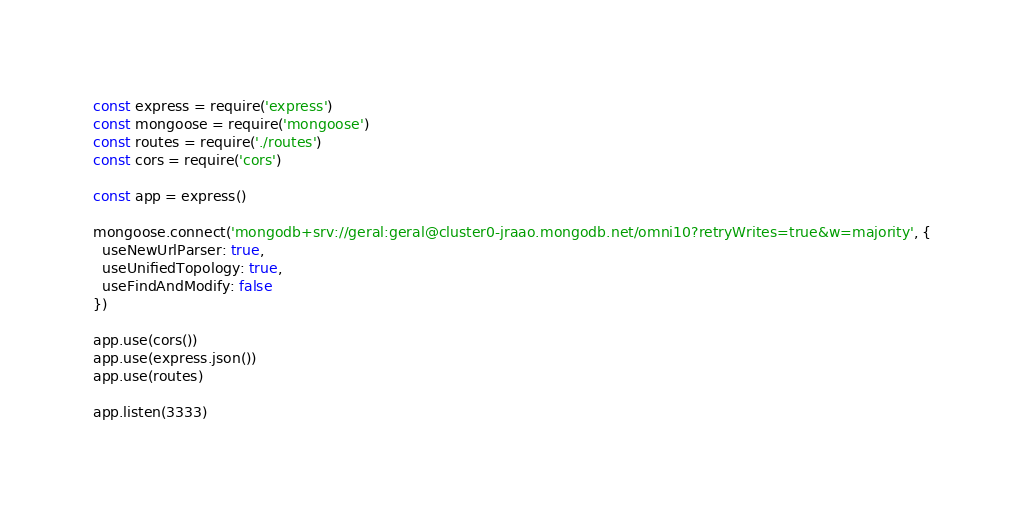<code> <loc_0><loc_0><loc_500><loc_500><_JavaScript_>const express = require('express')
const mongoose = require('mongoose')
const routes = require('./routes')
const cors = require('cors')

const app = express()

mongoose.connect('mongodb+srv://geral:geral@cluster0-jraao.mongodb.net/omni10?retryWrites=true&w=majority', {
  useNewUrlParser: true,
  useUnifiedTopology: true,
  useFindAndModify: false 
})

app.use(cors())
app.use(express.json())
app.use(routes)

app.listen(3333)</code> 